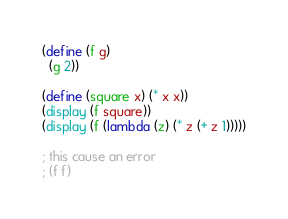<code> <loc_0><loc_0><loc_500><loc_500><_Scheme_>(define (f g)
  (g 2))

(define (square x) (* x x))
(display (f square))
(display (f (lambda (z) (* z (+ z 1)))))

; this cause an error
; (f f)

</code> 